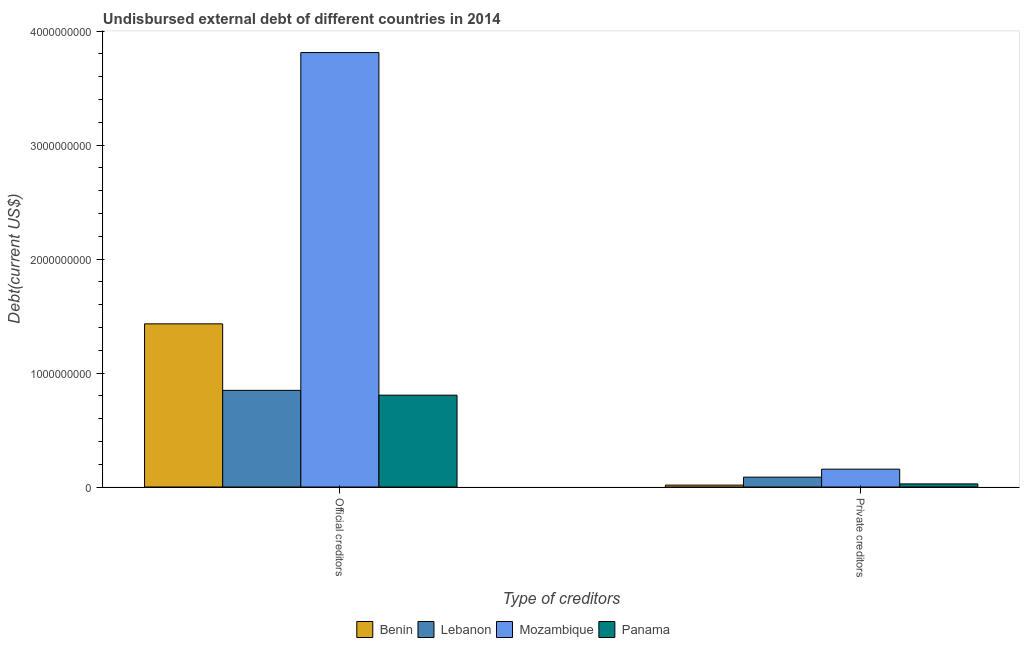How many different coloured bars are there?
Your response must be concise. 4. How many groups of bars are there?
Provide a succinct answer. 2. How many bars are there on the 1st tick from the right?
Provide a short and direct response. 4. What is the label of the 2nd group of bars from the left?
Ensure brevity in your answer.  Private creditors. What is the undisbursed external debt of private creditors in Benin?
Provide a short and direct response. 1.67e+07. Across all countries, what is the maximum undisbursed external debt of private creditors?
Provide a succinct answer. 1.57e+08. Across all countries, what is the minimum undisbursed external debt of private creditors?
Provide a succinct answer. 1.67e+07. In which country was the undisbursed external debt of official creditors maximum?
Ensure brevity in your answer.  Mozambique. In which country was the undisbursed external debt of private creditors minimum?
Offer a very short reply. Benin. What is the total undisbursed external debt of official creditors in the graph?
Offer a very short reply. 6.90e+09. What is the difference between the undisbursed external debt of official creditors in Lebanon and that in Panama?
Offer a terse response. 4.23e+07. What is the difference between the undisbursed external debt of official creditors in Panama and the undisbursed external debt of private creditors in Mozambique?
Provide a short and direct response. 6.49e+08. What is the average undisbursed external debt of private creditors per country?
Ensure brevity in your answer.  7.18e+07. What is the difference between the undisbursed external debt of official creditors and undisbursed external debt of private creditors in Mozambique?
Your response must be concise. 3.66e+09. What is the ratio of the undisbursed external debt of official creditors in Mozambique to that in Lebanon?
Ensure brevity in your answer.  4.49. Is the undisbursed external debt of official creditors in Mozambique less than that in Benin?
Keep it short and to the point. No. In how many countries, is the undisbursed external debt of official creditors greater than the average undisbursed external debt of official creditors taken over all countries?
Provide a short and direct response. 1. What does the 4th bar from the left in Official creditors represents?
Provide a succinct answer. Panama. What does the 4th bar from the right in Official creditors represents?
Your answer should be compact. Benin. How many bars are there?
Offer a very short reply. 8. Are all the bars in the graph horizontal?
Offer a terse response. No. Are the values on the major ticks of Y-axis written in scientific E-notation?
Make the answer very short. No. Does the graph contain any zero values?
Keep it short and to the point. No. Where does the legend appear in the graph?
Provide a short and direct response. Bottom center. How many legend labels are there?
Your response must be concise. 4. What is the title of the graph?
Your response must be concise. Undisbursed external debt of different countries in 2014. Does "Iran" appear as one of the legend labels in the graph?
Your response must be concise. No. What is the label or title of the X-axis?
Offer a very short reply. Type of creditors. What is the label or title of the Y-axis?
Give a very brief answer. Debt(current US$). What is the Debt(current US$) in Benin in Official creditors?
Keep it short and to the point. 1.43e+09. What is the Debt(current US$) in Lebanon in Official creditors?
Your response must be concise. 8.48e+08. What is the Debt(current US$) in Mozambique in Official creditors?
Provide a succinct answer. 3.81e+09. What is the Debt(current US$) of Panama in Official creditors?
Your answer should be very brief. 8.06e+08. What is the Debt(current US$) in Benin in Private creditors?
Offer a very short reply. 1.67e+07. What is the Debt(current US$) in Lebanon in Private creditors?
Provide a succinct answer. 8.65e+07. What is the Debt(current US$) of Mozambique in Private creditors?
Provide a succinct answer. 1.57e+08. What is the Debt(current US$) of Panama in Private creditors?
Your answer should be compact. 2.74e+07. Across all Type of creditors, what is the maximum Debt(current US$) in Benin?
Offer a terse response. 1.43e+09. Across all Type of creditors, what is the maximum Debt(current US$) of Lebanon?
Provide a short and direct response. 8.48e+08. Across all Type of creditors, what is the maximum Debt(current US$) in Mozambique?
Keep it short and to the point. 3.81e+09. Across all Type of creditors, what is the maximum Debt(current US$) in Panama?
Ensure brevity in your answer.  8.06e+08. Across all Type of creditors, what is the minimum Debt(current US$) of Benin?
Provide a short and direct response. 1.67e+07. Across all Type of creditors, what is the minimum Debt(current US$) of Lebanon?
Provide a succinct answer. 8.65e+07. Across all Type of creditors, what is the minimum Debt(current US$) of Mozambique?
Offer a terse response. 1.57e+08. Across all Type of creditors, what is the minimum Debt(current US$) in Panama?
Provide a succinct answer. 2.74e+07. What is the total Debt(current US$) in Benin in the graph?
Offer a terse response. 1.45e+09. What is the total Debt(current US$) of Lebanon in the graph?
Keep it short and to the point. 9.35e+08. What is the total Debt(current US$) in Mozambique in the graph?
Ensure brevity in your answer.  3.97e+09. What is the total Debt(current US$) in Panama in the graph?
Give a very brief answer. 8.33e+08. What is the difference between the Debt(current US$) in Benin in Official creditors and that in Private creditors?
Offer a very short reply. 1.41e+09. What is the difference between the Debt(current US$) in Lebanon in Official creditors and that in Private creditors?
Provide a short and direct response. 7.62e+08. What is the difference between the Debt(current US$) of Mozambique in Official creditors and that in Private creditors?
Your answer should be compact. 3.66e+09. What is the difference between the Debt(current US$) of Panama in Official creditors and that in Private creditors?
Offer a very short reply. 7.78e+08. What is the difference between the Debt(current US$) of Benin in Official creditors and the Debt(current US$) of Lebanon in Private creditors?
Provide a succinct answer. 1.34e+09. What is the difference between the Debt(current US$) of Benin in Official creditors and the Debt(current US$) of Mozambique in Private creditors?
Give a very brief answer. 1.27e+09. What is the difference between the Debt(current US$) of Benin in Official creditors and the Debt(current US$) of Panama in Private creditors?
Offer a terse response. 1.40e+09. What is the difference between the Debt(current US$) in Lebanon in Official creditors and the Debt(current US$) in Mozambique in Private creditors?
Ensure brevity in your answer.  6.92e+08. What is the difference between the Debt(current US$) of Lebanon in Official creditors and the Debt(current US$) of Panama in Private creditors?
Keep it short and to the point. 8.21e+08. What is the difference between the Debt(current US$) of Mozambique in Official creditors and the Debt(current US$) of Panama in Private creditors?
Offer a terse response. 3.78e+09. What is the average Debt(current US$) of Benin per Type of creditors?
Your answer should be very brief. 7.24e+08. What is the average Debt(current US$) of Lebanon per Type of creditors?
Provide a short and direct response. 4.67e+08. What is the average Debt(current US$) in Mozambique per Type of creditors?
Make the answer very short. 1.98e+09. What is the average Debt(current US$) of Panama per Type of creditors?
Ensure brevity in your answer.  4.17e+08. What is the difference between the Debt(current US$) of Benin and Debt(current US$) of Lebanon in Official creditors?
Offer a very short reply. 5.83e+08. What is the difference between the Debt(current US$) in Benin and Debt(current US$) in Mozambique in Official creditors?
Your answer should be very brief. -2.38e+09. What is the difference between the Debt(current US$) in Benin and Debt(current US$) in Panama in Official creditors?
Offer a terse response. 6.26e+08. What is the difference between the Debt(current US$) in Lebanon and Debt(current US$) in Mozambique in Official creditors?
Provide a short and direct response. -2.96e+09. What is the difference between the Debt(current US$) of Lebanon and Debt(current US$) of Panama in Official creditors?
Offer a very short reply. 4.23e+07. What is the difference between the Debt(current US$) in Mozambique and Debt(current US$) in Panama in Official creditors?
Offer a terse response. 3.01e+09. What is the difference between the Debt(current US$) in Benin and Debt(current US$) in Lebanon in Private creditors?
Keep it short and to the point. -6.99e+07. What is the difference between the Debt(current US$) of Benin and Debt(current US$) of Mozambique in Private creditors?
Ensure brevity in your answer.  -1.40e+08. What is the difference between the Debt(current US$) of Benin and Debt(current US$) of Panama in Private creditors?
Keep it short and to the point. -1.07e+07. What is the difference between the Debt(current US$) of Lebanon and Debt(current US$) of Mozambique in Private creditors?
Offer a very short reply. -7.00e+07. What is the difference between the Debt(current US$) in Lebanon and Debt(current US$) in Panama in Private creditors?
Give a very brief answer. 5.91e+07. What is the difference between the Debt(current US$) of Mozambique and Debt(current US$) of Panama in Private creditors?
Provide a succinct answer. 1.29e+08. What is the ratio of the Debt(current US$) of Benin in Official creditors to that in Private creditors?
Your response must be concise. 85.93. What is the ratio of the Debt(current US$) in Lebanon in Official creditors to that in Private creditors?
Ensure brevity in your answer.  9.8. What is the ratio of the Debt(current US$) of Mozambique in Official creditors to that in Private creditors?
Offer a terse response. 24.35. What is the ratio of the Debt(current US$) in Panama in Official creditors to that in Private creditors?
Ensure brevity in your answer.  29.43. What is the difference between the highest and the second highest Debt(current US$) of Benin?
Ensure brevity in your answer.  1.41e+09. What is the difference between the highest and the second highest Debt(current US$) of Lebanon?
Offer a very short reply. 7.62e+08. What is the difference between the highest and the second highest Debt(current US$) of Mozambique?
Ensure brevity in your answer.  3.66e+09. What is the difference between the highest and the second highest Debt(current US$) in Panama?
Make the answer very short. 7.78e+08. What is the difference between the highest and the lowest Debt(current US$) of Benin?
Offer a terse response. 1.41e+09. What is the difference between the highest and the lowest Debt(current US$) of Lebanon?
Your response must be concise. 7.62e+08. What is the difference between the highest and the lowest Debt(current US$) of Mozambique?
Ensure brevity in your answer.  3.66e+09. What is the difference between the highest and the lowest Debt(current US$) in Panama?
Your answer should be very brief. 7.78e+08. 